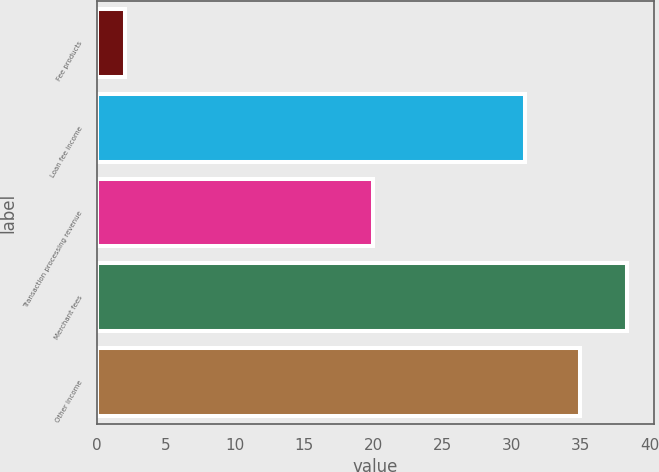<chart> <loc_0><loc_0><loc_500><loc_500><bar_chart><fcel>Fee products<fcel>Loan fee income<fcel>Transaction processing revenue<fcel>Merchant fees<fcel>Other income<nl><fcel>2<fcel>31<fcel>20<fcel>38.4<fcel>35<nl></chart> 